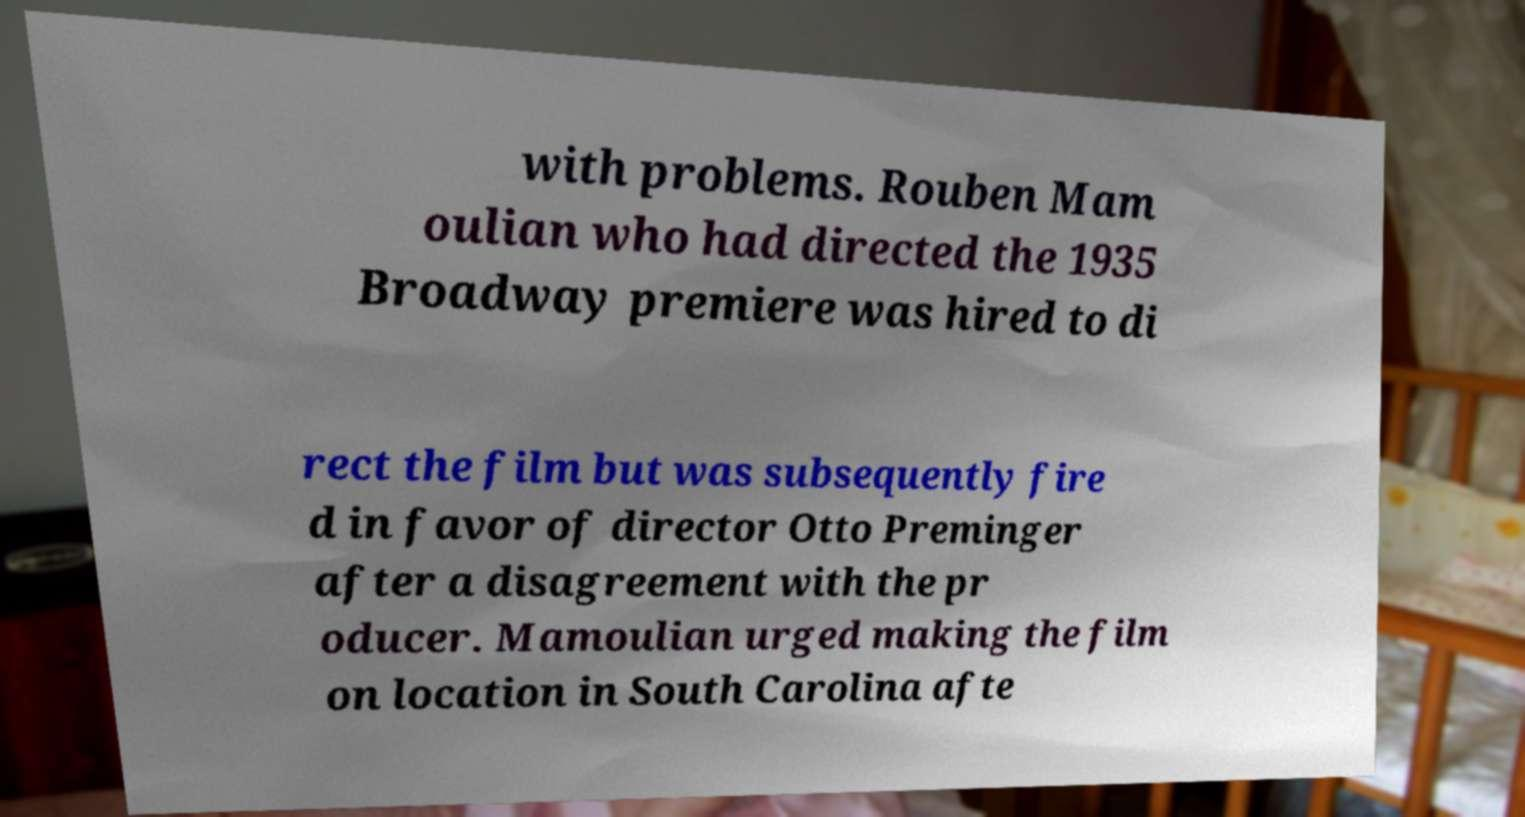Please read and relay the text visible in this image. What does it say? with problems. Rouben Mam oulian who had directed the 1935 Broadway premiere was hired to di rect the film but was subsequently fire d in favor of director Otto Preminger after a disagreement with the pr oducer. Mamoulian urged making the film on location in South Carolina afte 